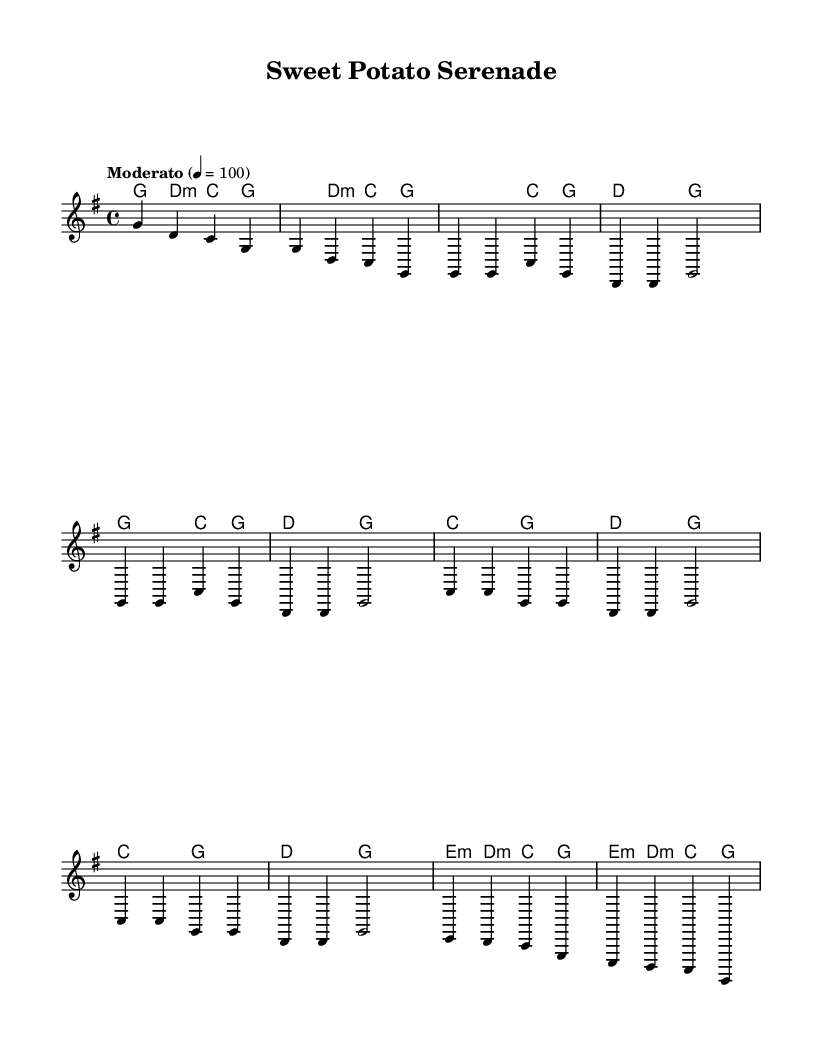What is the key signature of this music? The key signature is G major, which has one sharp (F#). This can be determined by looking at the key signature indicated at the beginning of the piece.
Answer: G major What is the time signature of this music? The time signature is 4/4, which means there are four beats in each measure and a quarter note gets one beat. This can be found at the beginning of the score, noting the "4/4" indicated.
Answer: 4/4 What is the tempo marking for the piece? The tempo marking is "Moderato," indicating a moderate speed, and it also states that the quarter note equals 100 beats per minute. This is noted in the tempo section of the score.
Answer: Moderato How many measures are in the verse section? The verse section consists of four measures, as indicated by the melody and harmony sections where it is labeled. Counting the measures from the score confirms this.
Answer: Four What chords are used in the chorus? The chords for the chorus are C major and D major, which are repeatedly played in the chorus section of the harmonies provided in the score.
Answer: C major, D major What is the last chord in the bridge? The last chord in the bridge is G major, which can be identified by checking the harmony at the end of the bridge section in the score.
Answer: G major What musical form does the piece represent? The piece represents a verse-chorus structure, which is typical for folk music, where the verse tells a story and is followed by a repeated chorus. The structure can be analyzed by looking at the layout of the melody and harmonies.
Answer: Verse-chorus 